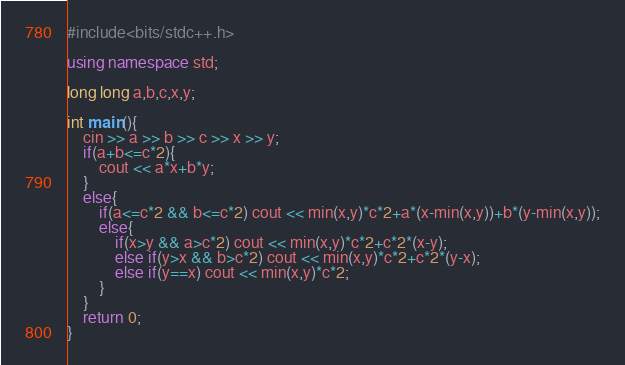<code> <loc_0><loc_0><loc_500><loc_500><_C++_>#include<bits/stdc++.h>

using namespace std;

long long a,b,c,x,y;

int main(){
	cin >> a >> b >> c >> x >> y;
	if(a+b<=c*2){
		cout << a*x+b*y;
	}
	else{
		if(a<=c*2 && b<=c*2) cout << min(x,y)*c*2+a*(x-min(x,y))+b*(y-min(x,y));
		else{
			if(x>y && a>c*2) cout << min(x,y)*c*2+c*2*(x-y);
			else if(y>x && b>c*2) cout << min(x,y)*c*2+c*2*(y-x);
			else if(y==x) cout << min(x,y)*c*2;
		}
	}
	return 0;
}</code> 